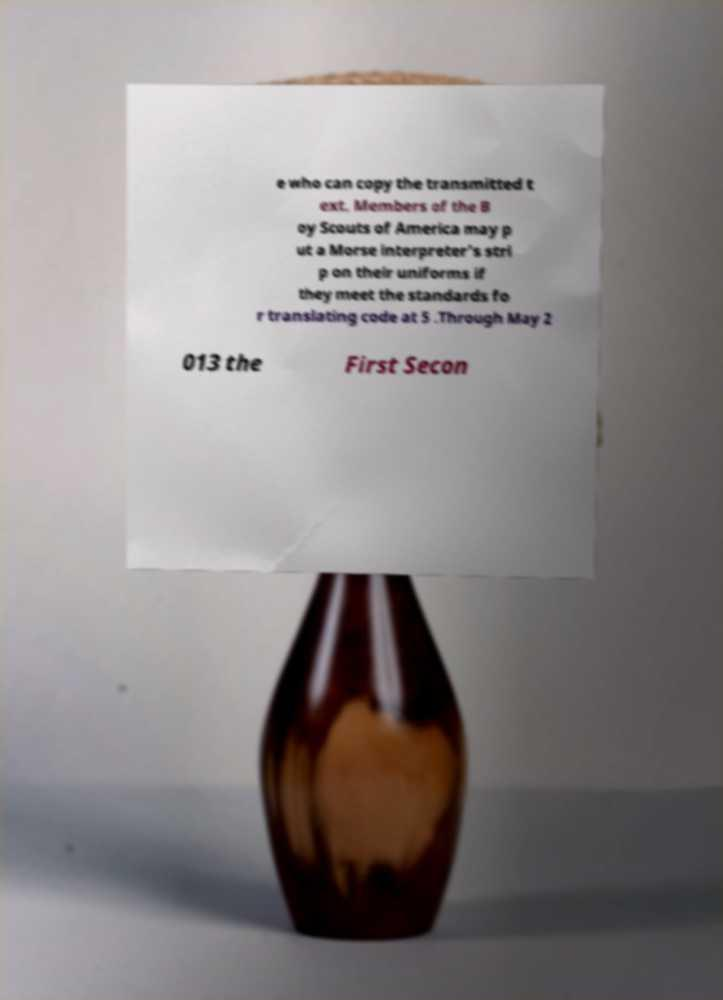For documentation purposes, I need the text within this image transcribed. Could you provide that? e who can copy the transmitted t ext. Members of the B oy Scouts of America may p ut a Morse interpreter's stri p on their uniforms if they meet the standards fo r translating code at 5 .Through May 2 013 the First Secon 